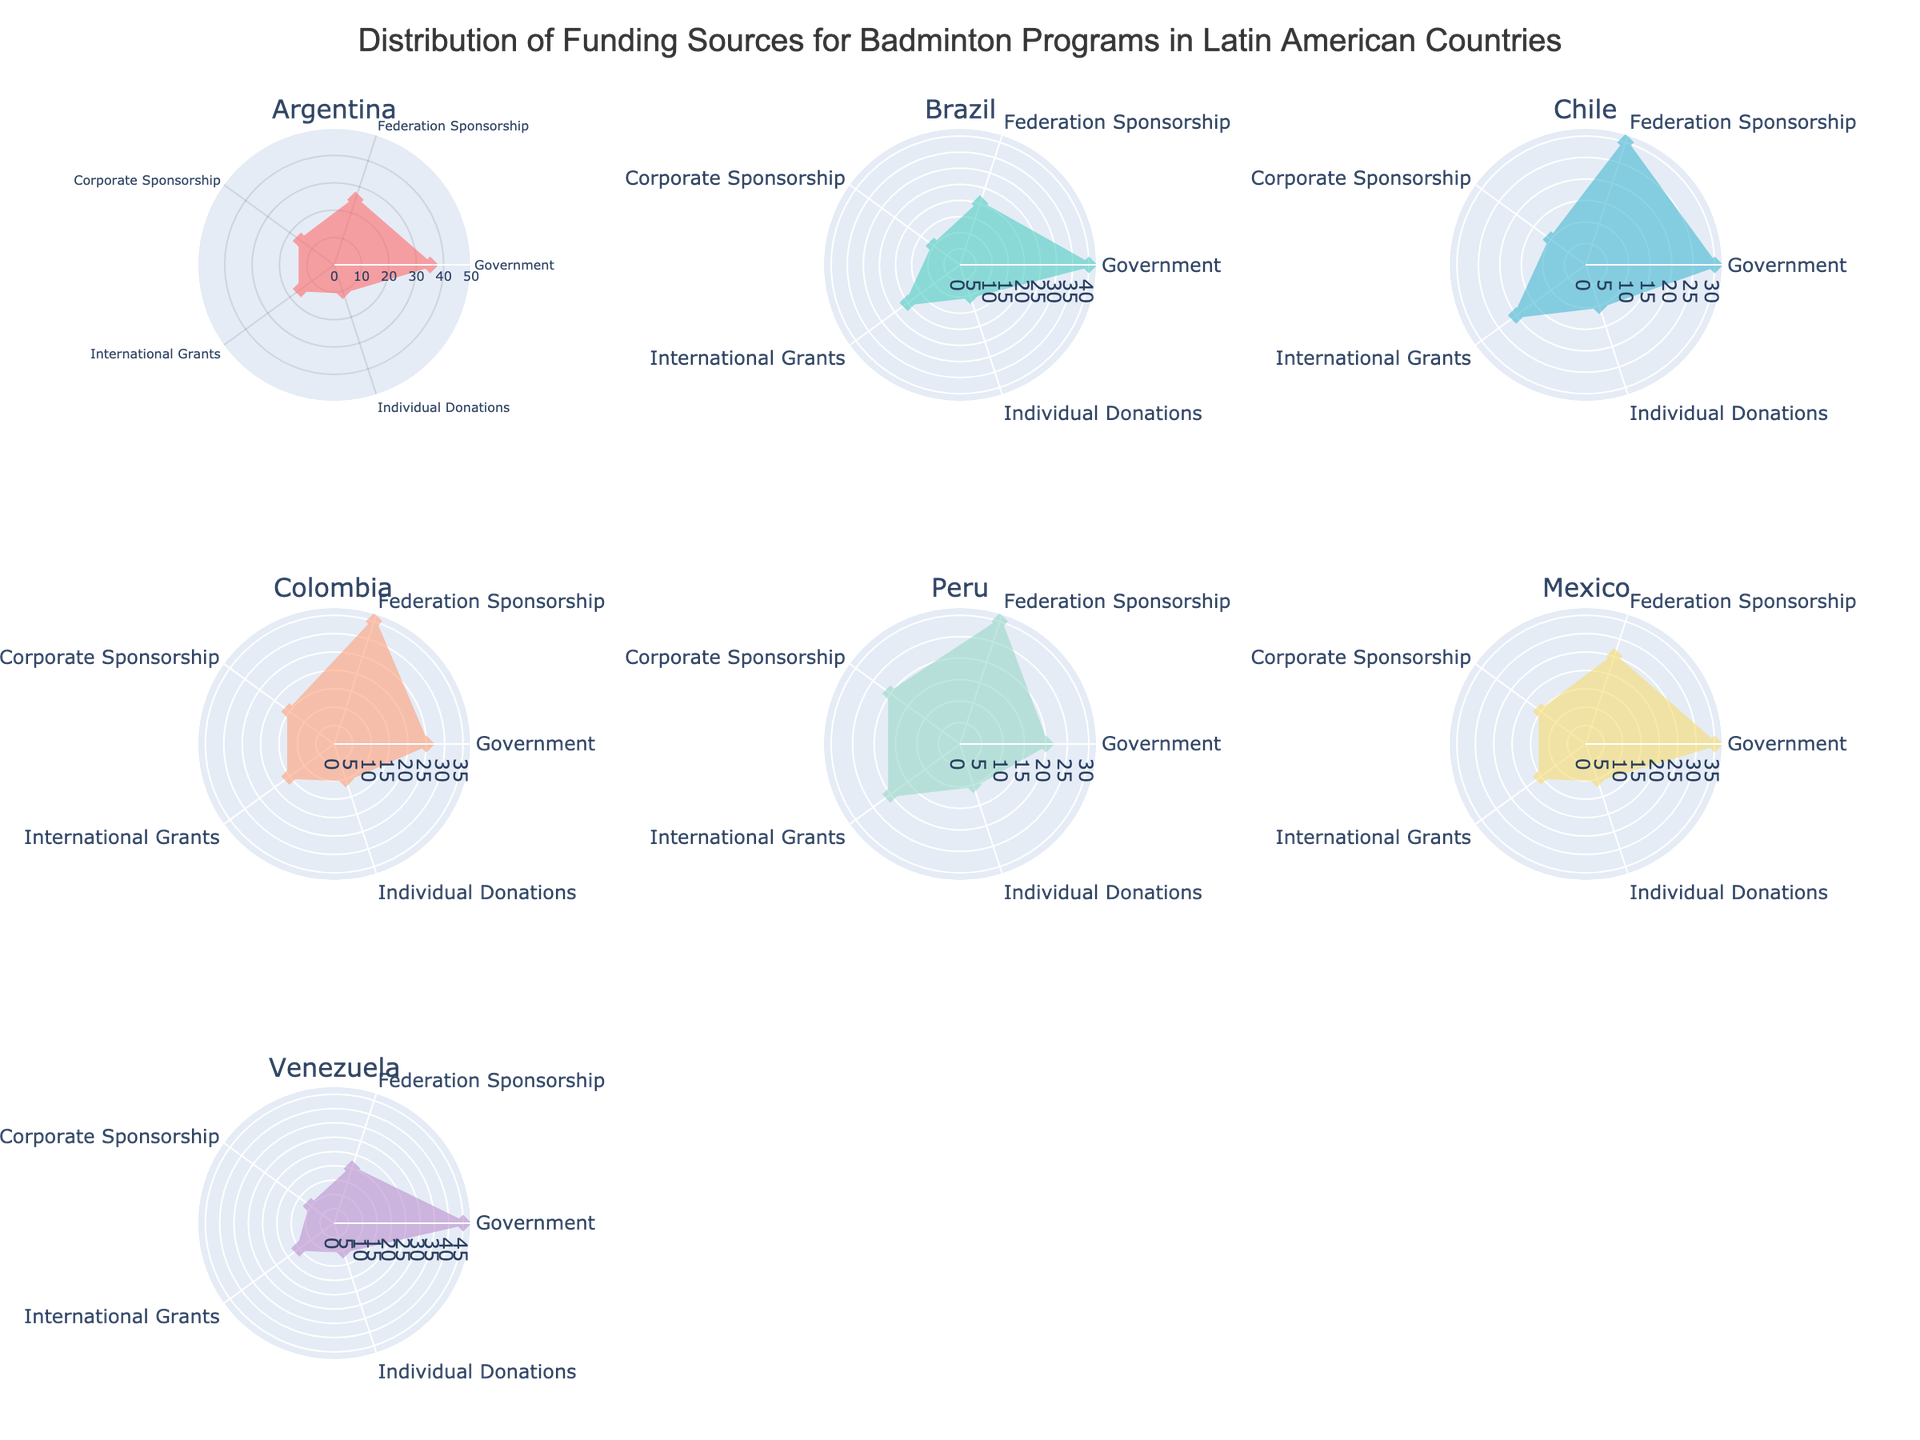What categories are displayed in the radar plot? The radar plots depict five categories: Government, Federation Sponsorship, Corporate Sponsorship, International Grants, and Individual Donations. These categories represent different sources of funding for badminton programs.
Answer: Government, Federation Sponsorship, Corporate Sponsorship, International Grants, Individual Donations Which country receives the highest percentage of funding from the government? By examining the radar subplots, Venezuela has the highest value in the Government category, which is visually apparent as the segments connecting the government funding of Venezuela extend furthest.
Answer: Venezuela What is the average percentage of funding from Corporate Sponsorship across all countries? To find the average percentage of Corporate Sponsorship, we sum all values for Corporate Sponsorship and divide by the number of countries. The data values are 15, 10, 10, 15, 20, 15, 10 for each country respectively. Summing these values gives 95, divided by 7 (number of countries) gives 13.57 (rounded to 2 decimal places).
Answer: 13.57 Which country has the most balanced radar plot in terms of funding distribution? A balanced radar plot will have segments that are more evenly distributed. By looking at plots, Chile and Peru have relatively evenly spaced segments, showing a balanced distribution compared to others.
Answer: Chile, Peru How does the funding from International Grants in Colombia compare to that of Brazil? By examining the radar plots, both Colombia and Brazil have the same value in the International Grants category, which is 15%.
Answer: Equal What is the total funding percentage for Federation Sponsorship and Individual Donations in Argentina? For Argentina, Federation Sponsorship is 25%, and Individual Donations is 10%. Adding these gives a total of 35%.
Answer: 35% Which countries have government funding greater than or equal to 35%? From the radar plots, the countries with Government funding of 35% or more are Argentina, Brazil, Mexico, and Venezuela.
Answer: Argentina, Brazil, Mexico, Venezuela Which funding source in Peru has the highest percentage? By examining Peru's radar plot, we see that International Grants and Federation Sponsorship have the same highest percentage, which is 20%.
Answer: International Grants, Federation Sponsorship 